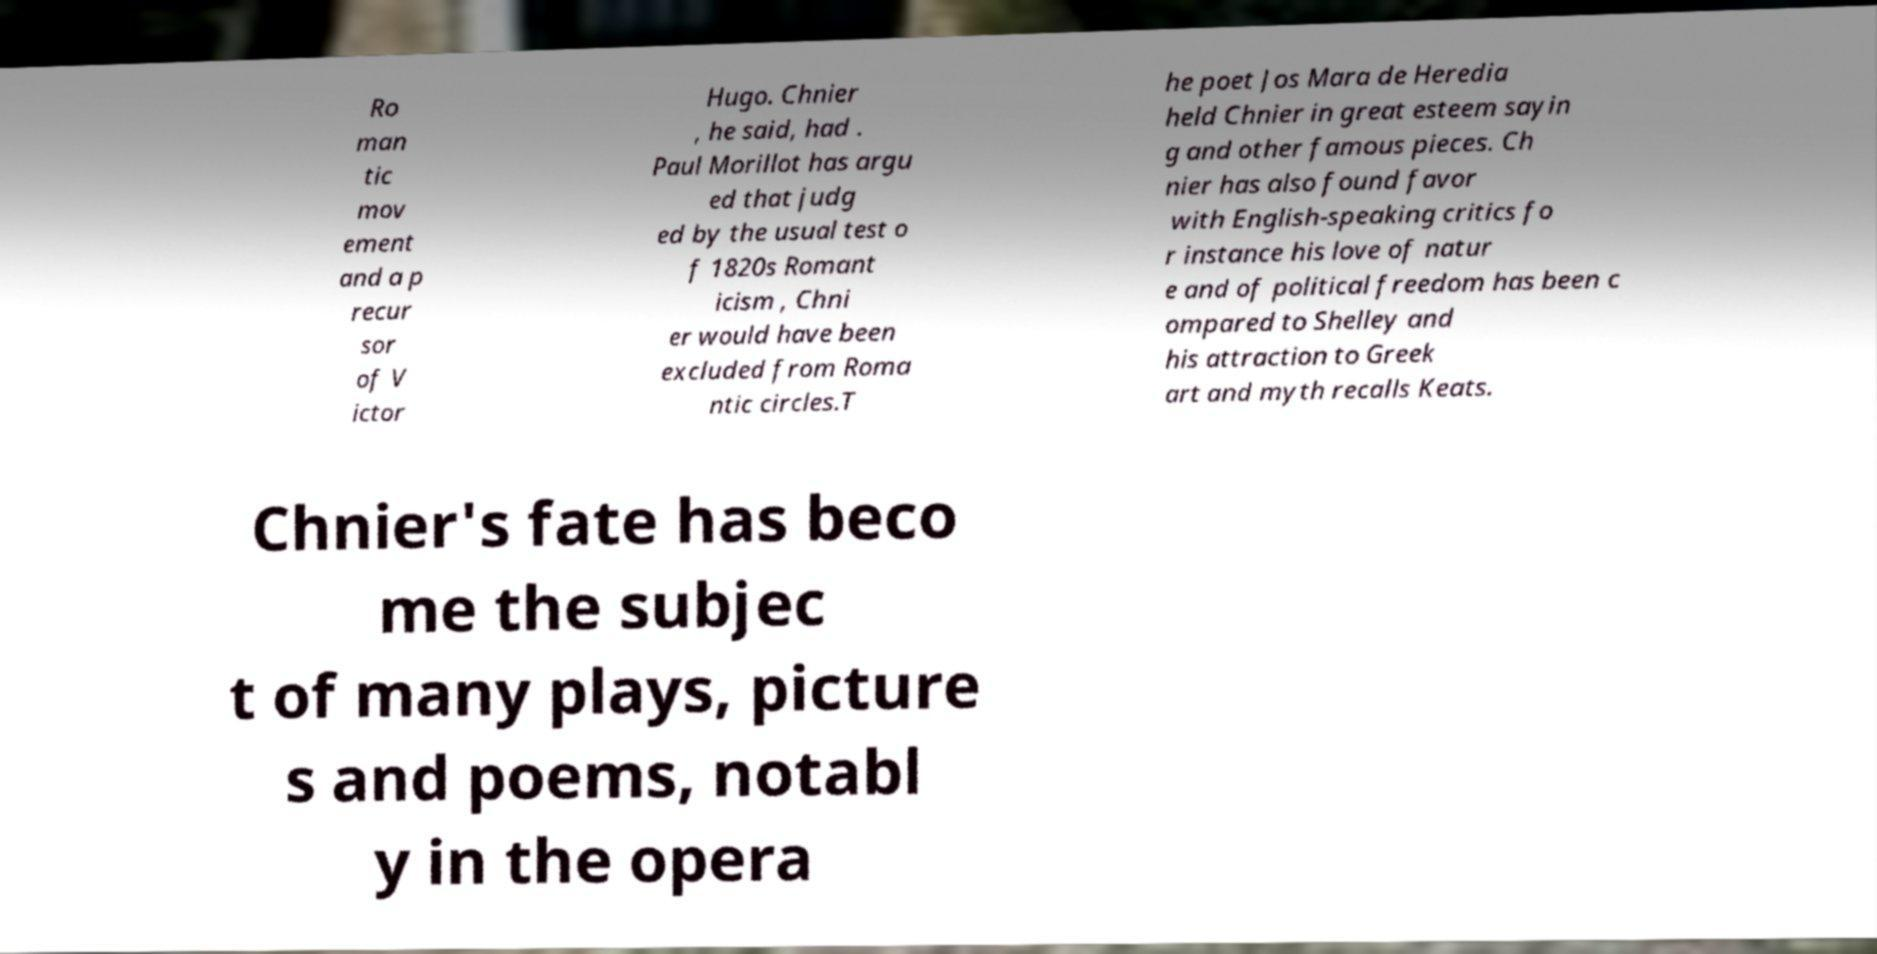Could you extract and type out the text from this image? Ro man tic mov ement and a p recur sor of V ictor Hugo. Chnier , he said, had . Paul Morillot has argu ed that judg ed by the usual test o f 1820s Romant icism , Chni er would have been excluded from Roma ntic circles.T he poet Jos Mara de Heredia held Chnier in great esteem sayin g and other famous pieces. Ch nier has also found favor with English-speaking critics fo r instance his love of natur e and of political freedom has been c ompared to Shelley and his attraction to Greek art and myth recalls Keats. Chnier's fate has beco me the subjec t of many plays, picture s and poems, notabl y in the opera 